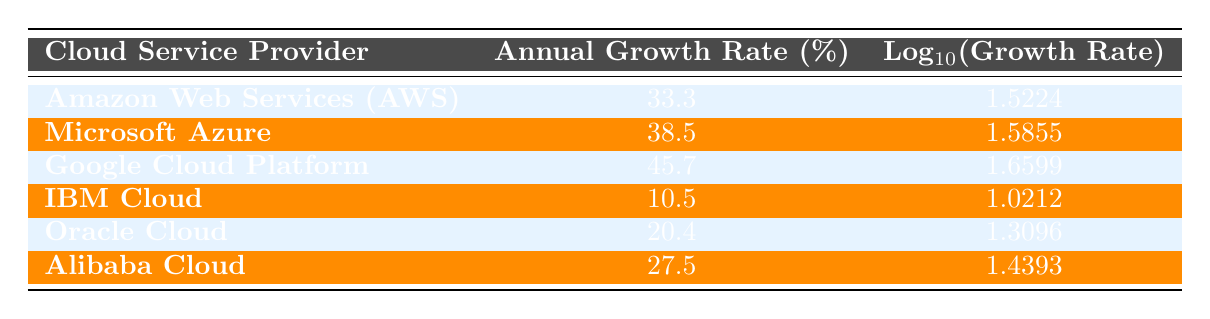What is the annual revenue growth rate of Microsoft Azure? The table lists the annual revenue growth rates for each provider, and the rate for Microsoft Azure is specifically mentioned as 38.5%.
Answer: 38.5% Which cloud service provider has the lowest annual revenue growth rate? By examining the annual growth rates in the table, IBM Cloud has the lowest value at 10.5%.
Answer: IBM Cloud What is the difference in annual revenue growth rates between Google Cloud Platform and Oracle Cloud? Google Cloud Platform's growth rate is 45.7%, and Oracle Cloud's rate is 20.4%. The difference is 45.7 - 20.4 = 25.3.
Answer: 25.3 Is the annual revenue growth rate of Alibaba Cloud greater than that of Amazon Web Services? Alibaba Cloud's growth rate is 27.5%, while Amazon Web Services' rate is 33.3%. Since 27.5 is less than 33.3, the statement is false.
Answer: No What is the average annual revenue growth rate of all cloud service providers listed? The growth rates are 33.3, 38.5, 45.7, 10.5, 20.4, and 27.5. Summing these gives 175.9, and dividing by 6 (the number of providers) results in an average of 29.3167, which rounds to approximately 29.3.
Answer: 29.3 Which provider has a greater annual revenue growth rate: Amazon Web Services or Alibaba Cloud? Amazon Web Services has a rate of 33.3% while Alibaba Cloud has a rate of 27.5%. Since 33.3 is greater than 27.5, the answer indicates that AWS has a greater growth rate.
Answer: Amazon Web Services What is the total combined annual revenue growth rate of Microsoft Azure and Google Cloud Platform? The growth rate for Microsoft Azure is 38.5%, and for Google Cloud Platform, it is 45.7%. Add these two rates: 38.5 + 45.7 = 84.2.
Answer: 84.2 Is there a cloud service provider with an annual revenue growth rate of exactly 20%? Oracle Cloud has a growth rate of 20.4%. Since this rate does not equal exactly 20%, the answer is no.
Answer: No 